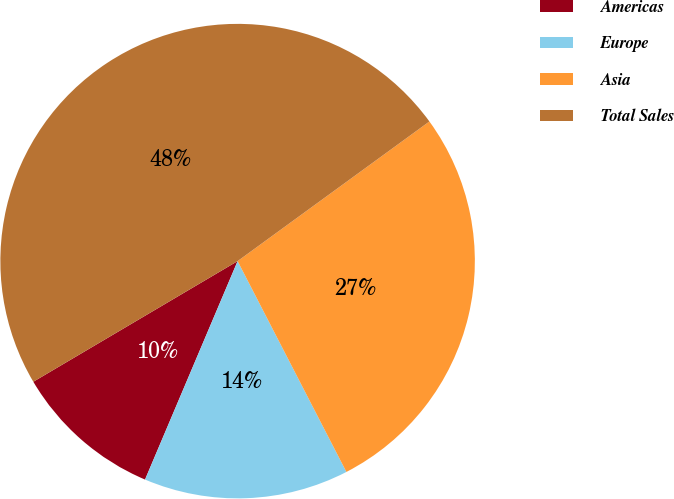Convert chart. <chart><loc_0><loc_0><loc_500><loc_500><pie_chart><fcel>Americas<fcel>Europe<fcel>Asia<fcel>Total Sales<nl><fcel>10.13%<fcel>13.96%<fcel>27.43%<fcel>48.47%<nl></chart> 